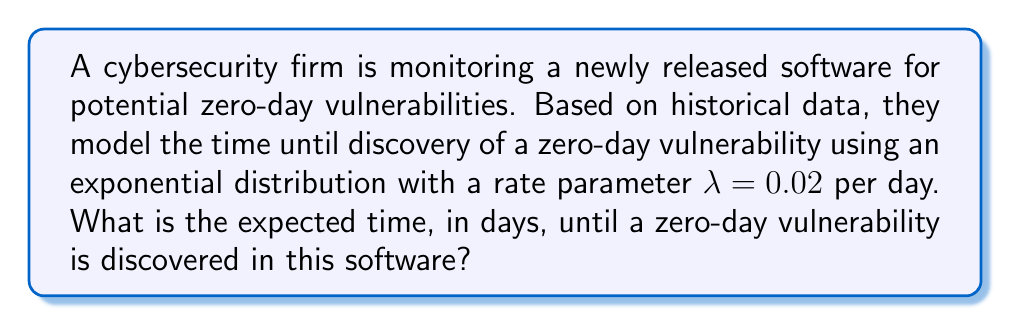Can you answer this question? To solve this problem, we'll use survival analysis techniques, specifically the properties of the exponential distribution:

1) The exponential distribution is commonly used in survival analysis to model the time until an event occurs.

2) For an exponential distribution with rate parameter $\lambda$, the expected value (mean) is given by:

   $$E[X] = \frac{1}{\lambda}$$

3) In this case, $\lambda = 0.02$ per day.

4) Substituting this value into the formula:

   $$E[X] = \frac{1}{0.02}$$

5) Simplifying:

   $$E[X] = 50$$

Therefore, the expected time until a zero-day vulnerability is discovered is 50 days.

This result aligns with the exponential distribution's memoryless property, which is relevant in cybersecurity as it suggests that the probability of discovering a vulnerability in the next time interval is constant, regardless of how long the software has been in use.
Answer: 50 days 